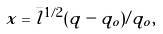<formula> <loc_0><loc_0><loc_500><loc_500>x = \bar { l } ^ { 1 / 2 } ( q - q _ { o } ) / q _ { o } ,</formula> 